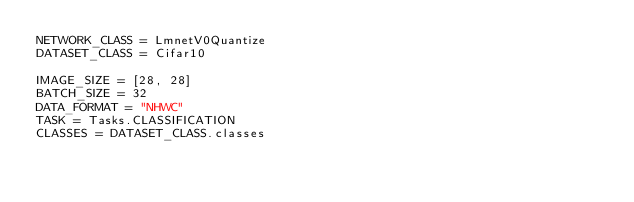<code> <loc_0><loc_0><loc_500><loc_500><_Python_>NETWORK_CLASS = LmnetV0Quantize
DATASET_CLASS = Cifar10

IMAGE_SIZE = [28, 28]
BATCH_SIZE = 32
DATA_FORMAT = "NHWC"
TASK = Tasks.CLASSIFICATION
CLASSES = DATASET_CLASS.classes
</code> 